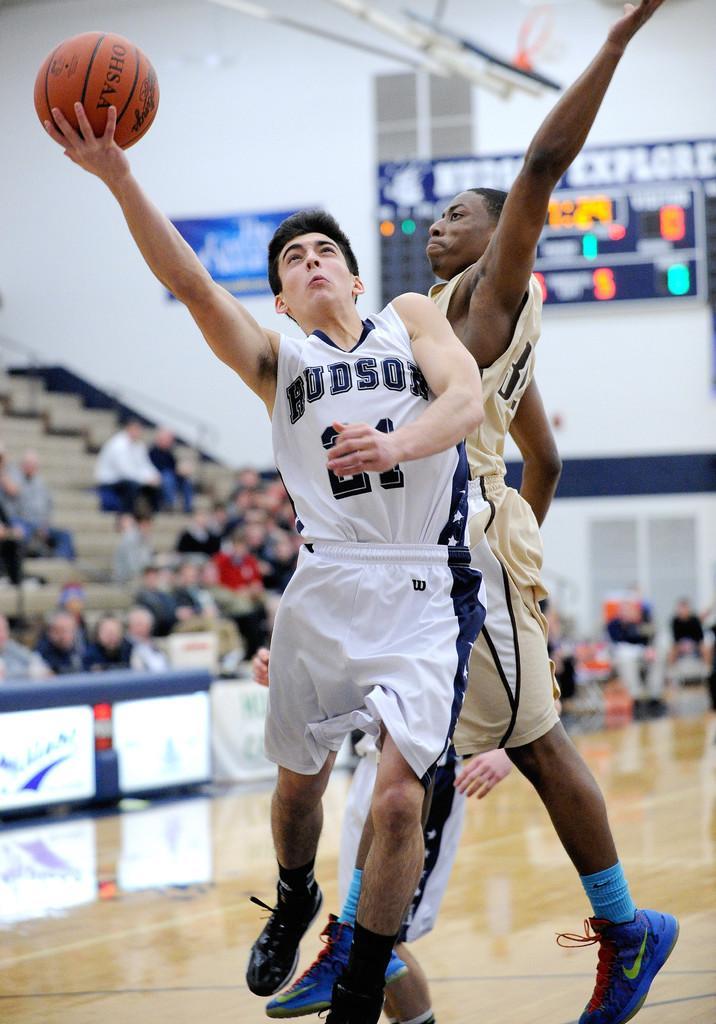Could you give a brief overview of what you see in this image? In this image, we can see two persons playing basketball. There are some persons on the left side of the image sitting on steps. 